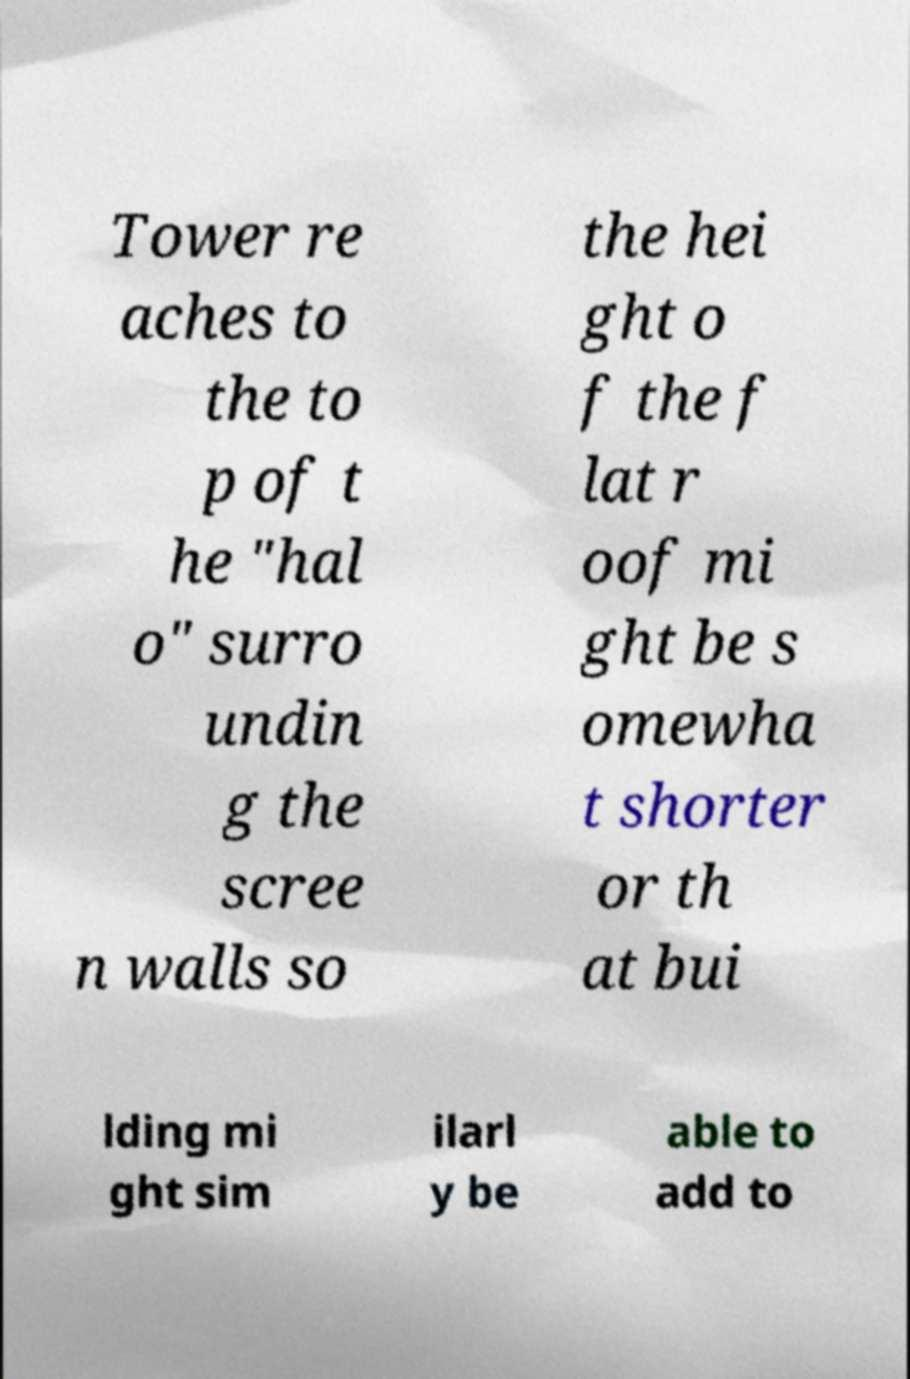For documentation purposes, I need the text within this image transcribed. Could you provide that? Tower re aches to the to p of t he "hal o" surro undin g the scree n walls so the hei ght o f the f lat r oof mi ght be s omewha t shorter or th at bui lding mi ght sim ilarl y be able to add to 